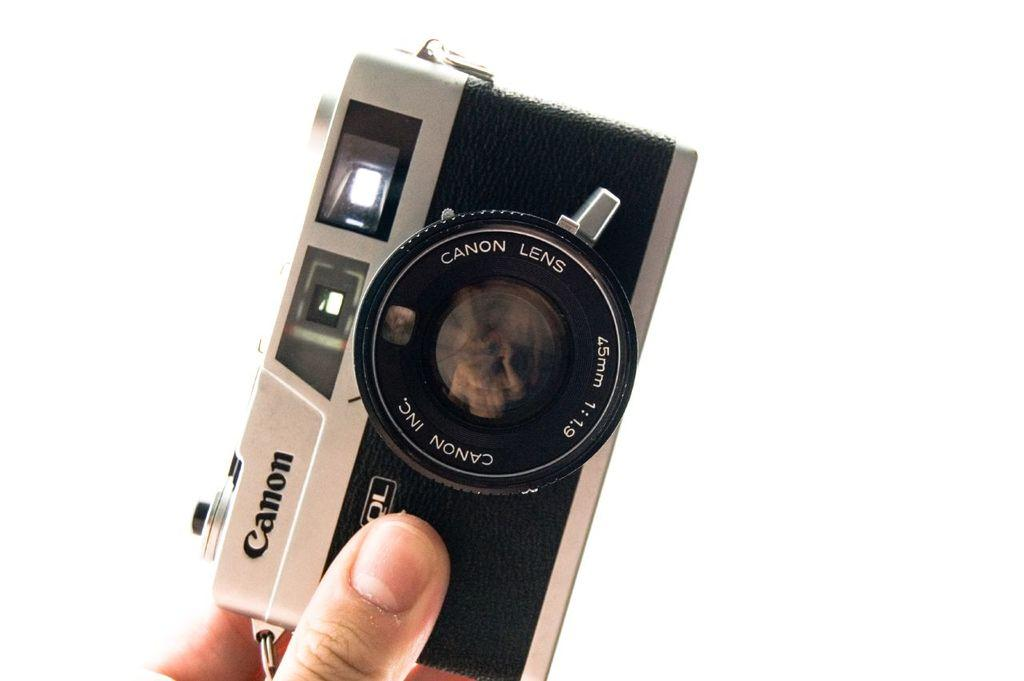What is the person in the picture holding? The person is holding a camera in the picture. What are some features of the camera? The camera has a lens, a flashlight, and buttons. What can be seen behind the person and the camera? The backdrop of the image features a white surface. How many cats are sitting on the person's arm in the image? There are no cats present in the image. What is the person's mind doing in the image? The person's mind is not visible in the image, so it cannot be determined what it is doing. 